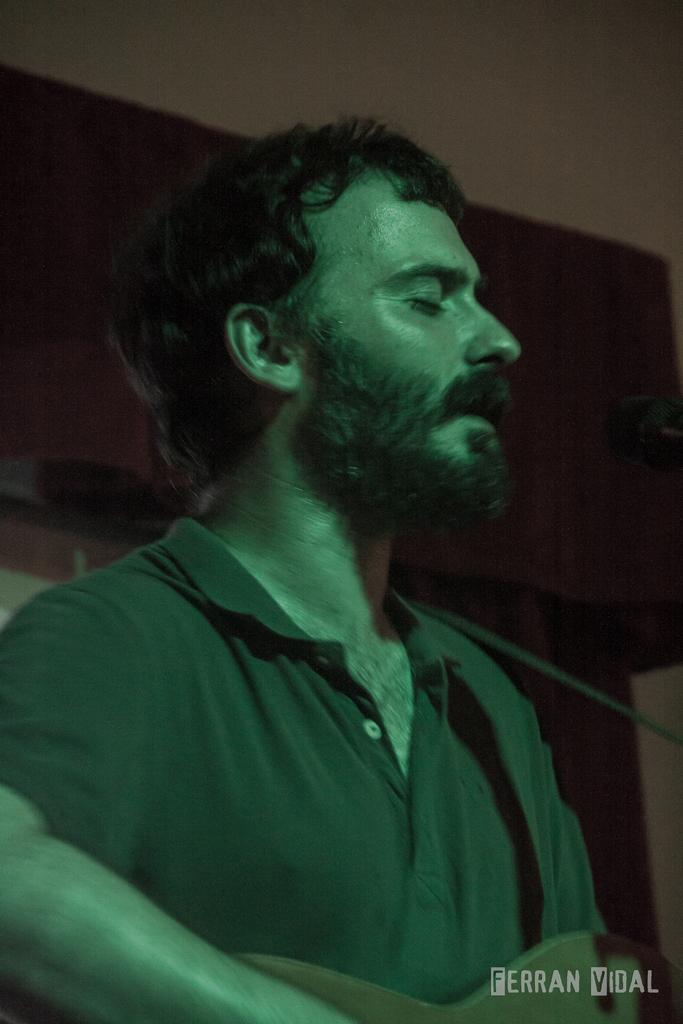What is the man in the image doing? The man is playing an instrument and singing a song. What can be inferred about the man's activity in the image? The man is likely performing music, given that he is playing an instrument and singing. How is the man being illuminated in the image? There is a green color light focusing on the man. What type of rod is the man using to catch fish in the image? There is no rod or fishing activity present in the image; the man is playing an instrument and singing. 